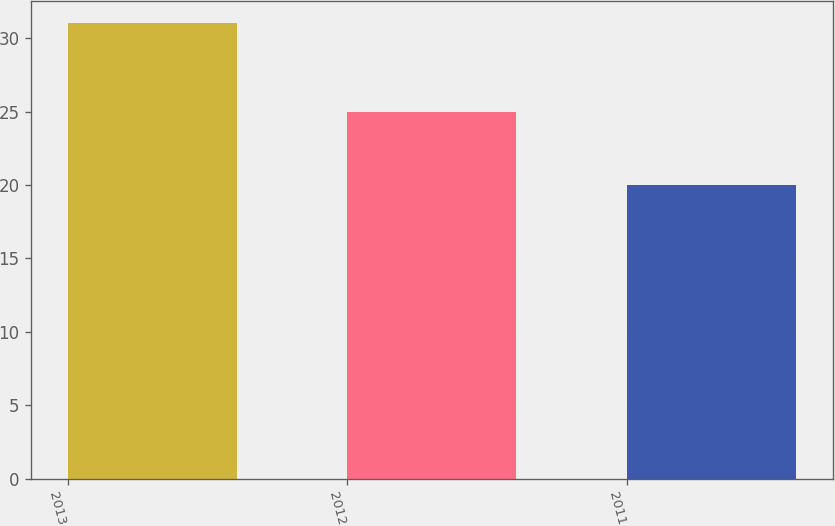Convert chart. <chart><loc_0><loc_0><loc_500><loc_500><bar_chart><fcel>2013<fcel>2012<fcel>2011<nl><fcel>31<fcel>25<fcel>20<nl></chart> 